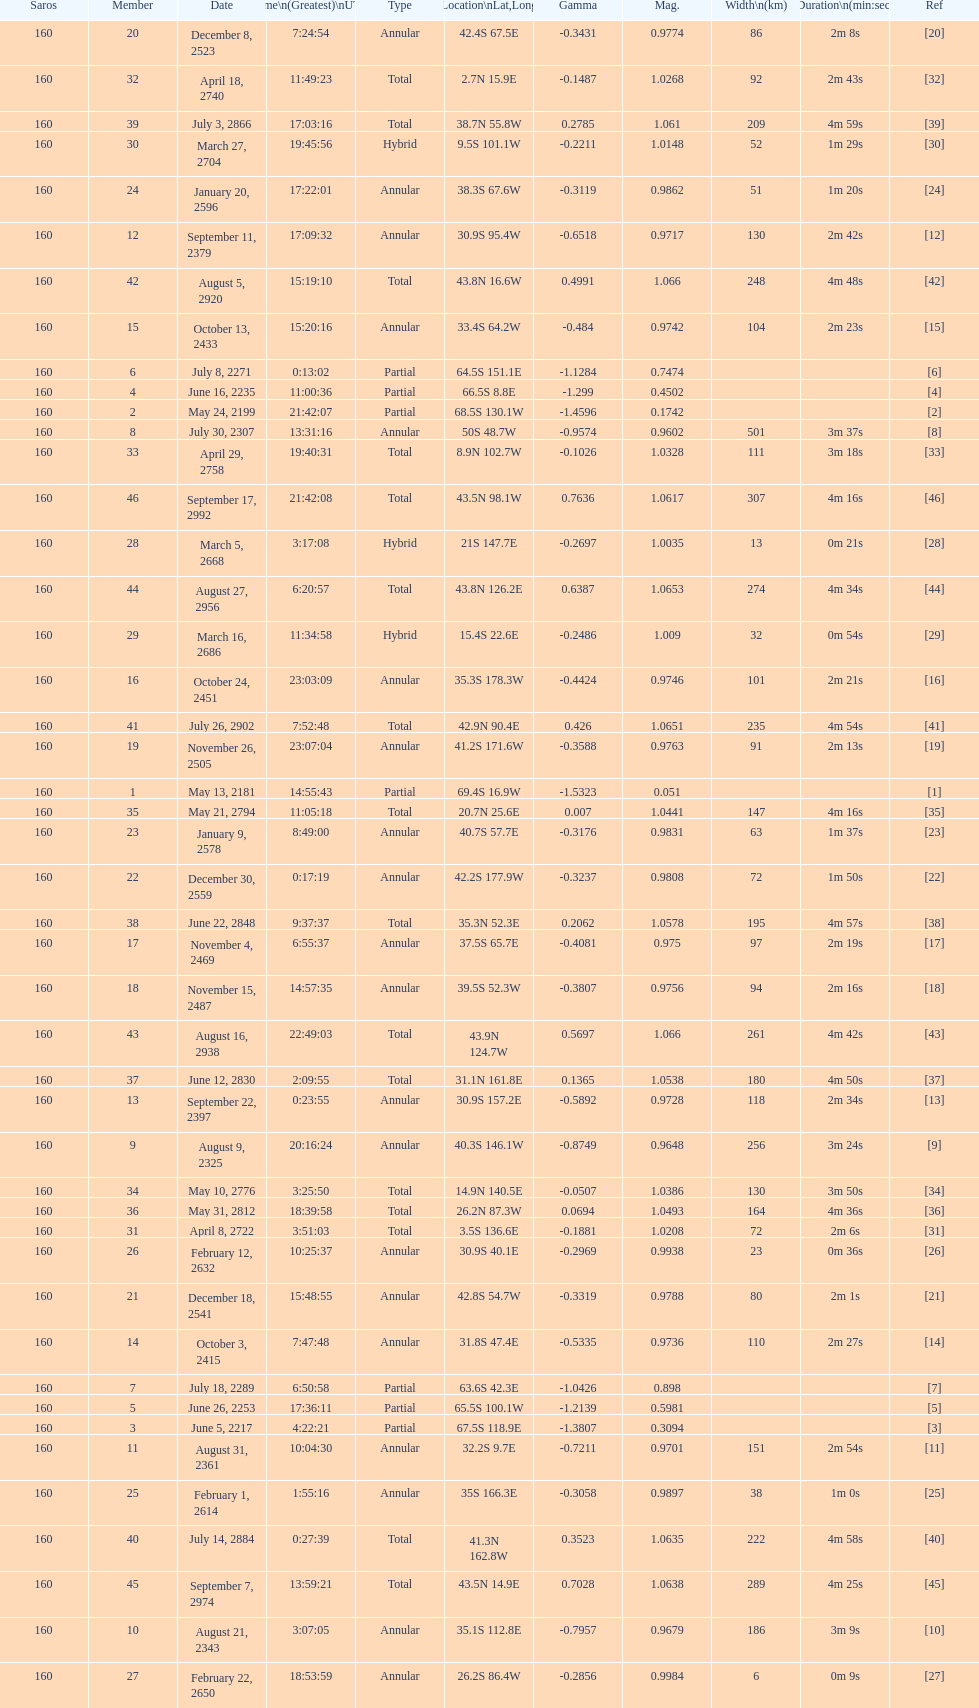How many total events will occur in all? 46. 